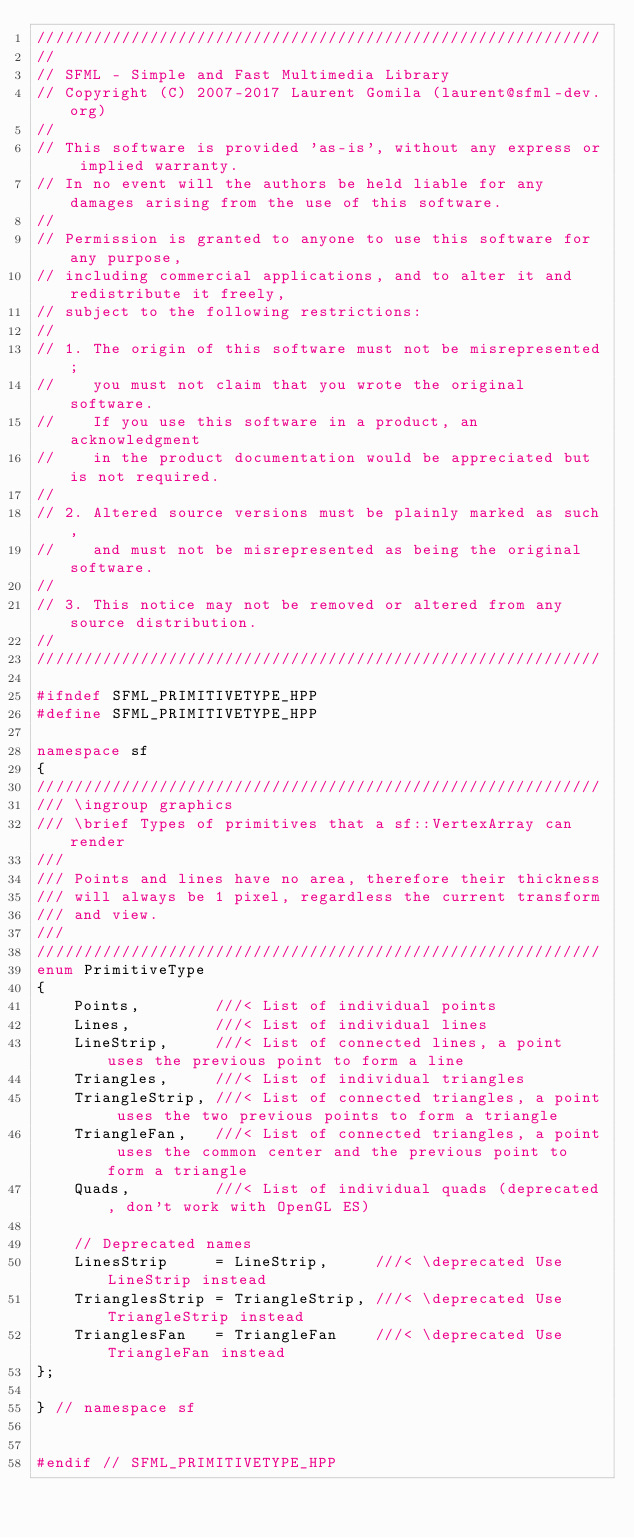<code> <loc_0><loc_0><loc_500><loc_500><_C++_>////////////////////////////////////////////////////////////
//
// SFML - Simple and Fast Multimedia Library
// Copyright (C) 2007-2017 Laurent Gomila (laurent@sfml-dev.org)
//
// This software is provided 'as-is', without any express or implied warranty.
// In no event will the authors be held liable for any damages arising from the use of this software.
//
// Permission is granted to anyone to use this software for any purpose,
// including commercial applications, and to alter it and redistribute it freely,
// subject to the following restrictions:
//
// 1. The origin of this software must not be misrepresented;
//    you must not claim that you wrote the original software.
//    If you use this software in a product, an acknowledgment
//    in the product documentation would be appreciated but is not required.
//
// 2. Altered source versions must be plainly marked as such,
//    and must not be misrepresented as being the original software.
//
// 3. This notice may not be removed or altered from any source distribution.
//
////////////////////////////////////////////////////////////

#ifndef SFML_PRIMITIVETYPE_HPP
#define SFML_PRIMITIVETYPE_HPP

namespace sf
{
////////////////////////////////////////////////////////////
/// \ingroup graphics
/// \brief Types of primitives that a sf::VertexArray can render
///
/// Points and lines have no area, therefore their thickness
/// will always be 1 pixel, regardless the current transform
/// and view.
///
////////////////////////////////////////////////////////////
enum PrimitiveType
{
    Points,        ///< List of individual points
    Lines,         ///< List of individual lines
    LineStrip,     ///< List of connected lines, a point uses the previous point to form a line
    Triangles,     ///< List of individual triangles
    TriangleStrip, ///< List of connected triangles, a point uses the two previous points to form a triangle
    TriangleFan,   ///< List of connected triangles, a point uses the common center and the previous point to form a triangle
    Quads,         ///< List of individual quads (deprecated, don't work with OpenGL ES)

    // Deprecated names
    LinesStrip     = LineStrip,     ///< \deprecated Use LineStrip instead
    TrianglesStrip = TriangleStrip, ///< \deprecated Use TriangleStrip instead
    TrianglesFan   = TriangleFan    ///< \deprecated Use TriangleFan instead
};

} // namespace sf


#endif // SFML_PRIMITIVETYPE_HPP
</code> 